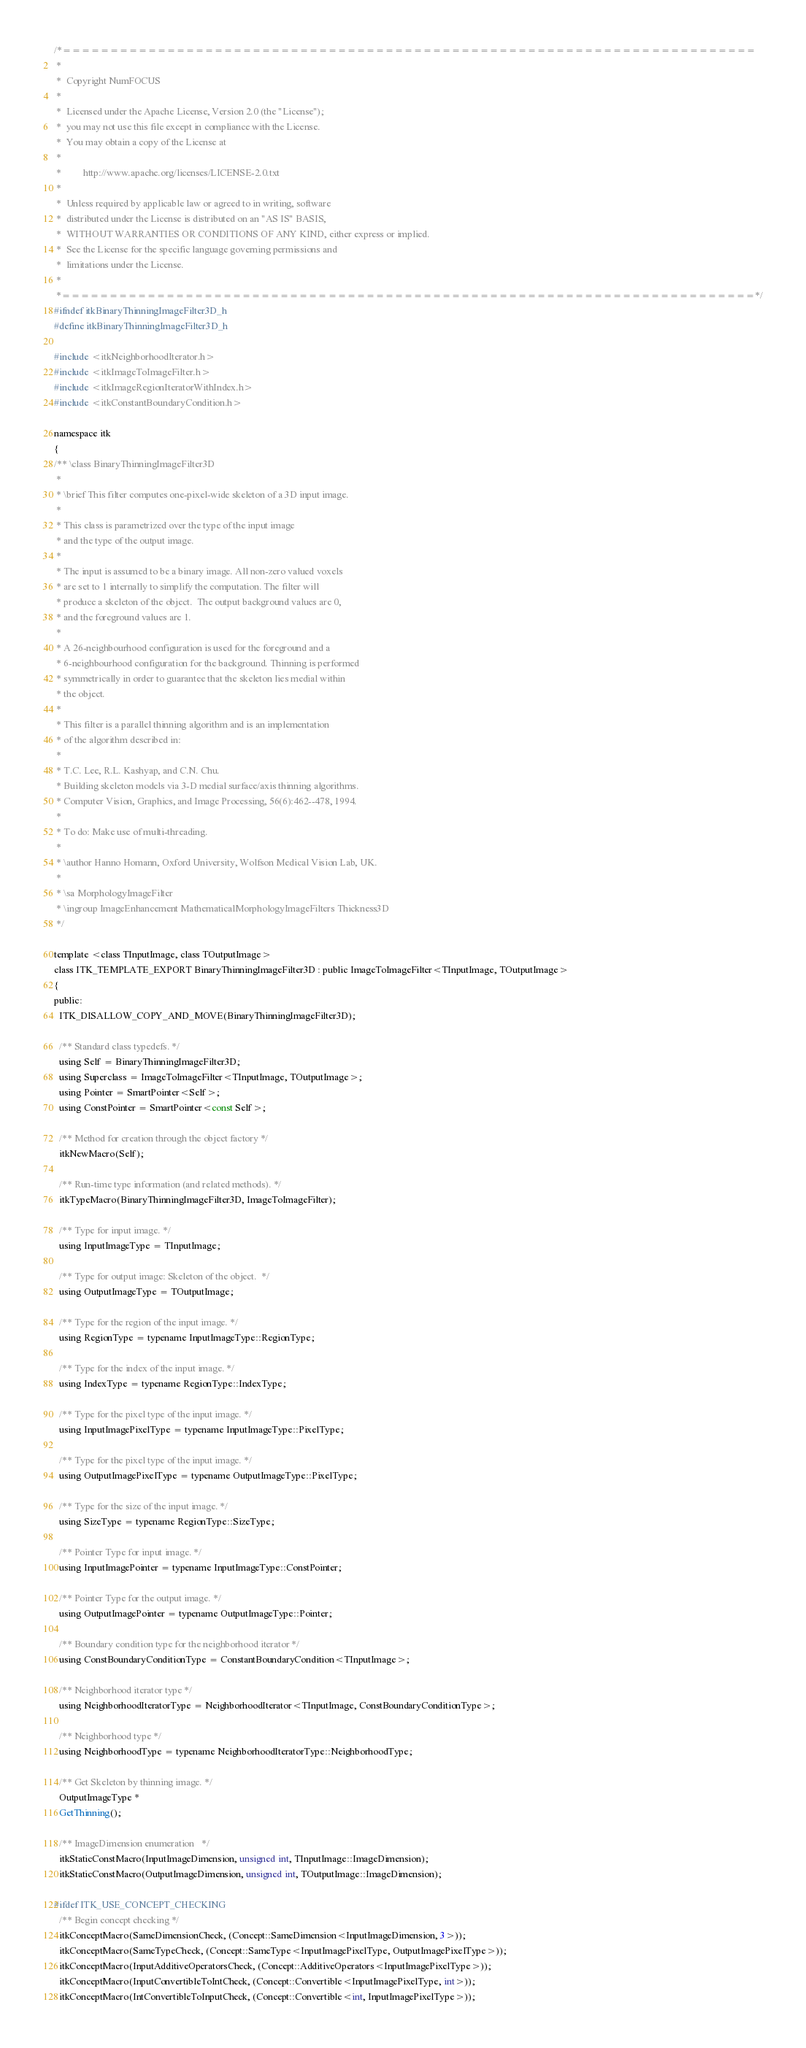Convert code to text. <code><loc_0><loc_0><loc_500><loc_500><_C_>/*=========================================================================
 *
 *  Copyright NumFOCUS
 *
 *  Licensed under the Apache License, Version 2.0 (the "License");
 *  you may not use this file except in compliance with the License.
 *  You may obtain a copy of the License at
 *
 *         http://www.apache.org/licenses/LICENSE-2.0.txt
 *
 *  Unless required by applicable law or agreed to in writing, software
 *  distributed under the License is distributed on an "AS IS" BASIS,
 *  WITHOUT WARRANTIES OR CONDITIONS OF ANY KIND, either express or implied.
 *  See the License for the specific language governing permissions and
 *  limitations under the License.
 *
 *=========================================================================*/
#ifndef itkBinaryThinningImageFilter3D_h
#define itkBinaryThinningImageFilter3D_h

#include <itkNeighborhoodIterator.h>
#include <itkImageToImageFilter.h>
#include <itkImageRegionIteratorWithIndex.h>
#include <itkConstantBoundaryCondition.h>

namespace itk
{
/** \class BinaryThinningImageFilter3D
 *
 * \brief This filter computes one-pixel-wide skeleton of a 3D input image.
 *
 * This class is parametrized over the type of the input image
 * and the type of the output image.
 *
 * The input is assumed to be a binary image. All non-zero valued voxels
 * are set to 1 internally to simplify the computation. The filter will
 * produce a skeleton of the object.  The output background values are 0,
 * and the foreground values are 1.
 *
 * A 26-neighbourhood configuration is used for the foreground and a
 * 6-neighbourhood configuration for the background. Thinning is performed
 * symmetrically in order to guarantee that the skeleton lies medial within
 * the object.
 *
 * This filter is a parallel thinning algorithm and is an implementation
 * of the algorithm described in:
 *
 * T.C. Lee, R.L. Kashyap, and C.N. Chu.
 * Building skeleton models via 3-D medial surface/axis thinning algorithms.
 * Computer Vision, Graphics, and Image Processing, 56(6):462--478, 1994.
 *
 * To do: Make use of multi-threading.
 *
 * \author Hanno Homann, Oxford University, Wolfson Medical Vision Lab, UK.
 *
 * \sa MorphologyImageFilter
 * \ingroup ImageEnhancement MathematicalMorphologyImageFilters Thickness3D
 */

template <class TInputImage, class TOutputImage>
class ITK_TEMPLATE_EXPORT BinaryThinningImageFilter3D : public ImageToImageFilter<TInputImage, TOutputImage>
{
public:
  ITK_DISALLOW_COPY_AND_MOVE(BinaryThinningImageFilter3D);

  /** Standard class typedefs. */
  using Self = BinaryThinningImageFilter3D;
  using Superclass = ImageToImageFilter<TInputImage, TOutputImage>;
  using Pointer = SmartPointer<Self>;
  using ConstPointer = SmartPointer<const Self>;

  /** Method for creation through the object factory */
  itkNewMacro(Self);

  /** Run-time type information (and related methods). */
  itkTypeMacro(BinaryThinningImageFilter3D, ImageToImageFilter);

  /** Type for input image. */
  using InputImageType = TInputImage;

  /** Type for output image: Skeleton of the object.  */
  using OutputImageType = TOutputImage;

  /** Type for the region of the input image. */
  using RegionType = typename InputImageType::RegionType;

  /** Type for the index of the input image. */
  using IndexType = typename RegionType::IndexType;

  /** Type for the pixel type of the input image. */
  using InputImagePixelType = typename InputImageType::PixelType;

  /** Type for the pixel type of the input image. */
  using OutputImagePixelType = typename OutputImageType::PixelType;

  /** Type for the size of the input image. */
  using SizeType = typename RegionType::SizeType;

  /** Pointer Type for input image. */
  using InputImagePointer = typename InputImageType::ConstPointer;

  /** Pointer Type for the output image. */
  using OutputImagePointer = typename OutputImageType::Pointer;

  /** Boundary condition type for the neighborhood iterator */
  using ConstBoundaryConditionType = ConstantBoundaryCondition<TInputImage>;

  /** Neighborhood iterator type */
  using NeighborhoodIteratorType = NeighborhoodIterator<TInputImage, ConstBoundaryConditionType>;

  /** Neighborhood type */
  using NeighborhoodType = typename NeighborhoodIteratorType::NeighborhoodType;

  /** Get Skeleton by thinning image. */
  OutputImageType *
  GetThinning();

  /** ImageDimension enumeration   */
  itkStaticConstMacro(InputImageDimension, unsigned int, TInputImage::ImageDimension);
  itkStaticConstMacro(OutputImageDimension, unsigned int, TOutputImage::ImageDimension);

#ifdef ITK_USE_CONCEPT_CHECKING
  /** Begin concept checking */
  itkConceptMacro(SameDimensionCheck, (Concept::SameDimension<InputImageDimension, 3>));
  itkConceptMacro(SameTypeCheck, (Concept::SameType<InputImagePixelType, OutputImagePixelType>));
  itkConceptMacro(InputAdditiveOperatorsCheck, (Concept::AdditiveOperators<InputImagePixelType>));
  itkConceptMacro(InputConvertibleToIntCheck, (Concept::Convertible<InputImagePixelType, int>));
  itkConceptMacro(IntConvertibleToInputCheck, (Concept::Convertible<int, InputImagePixelType>));</code> 